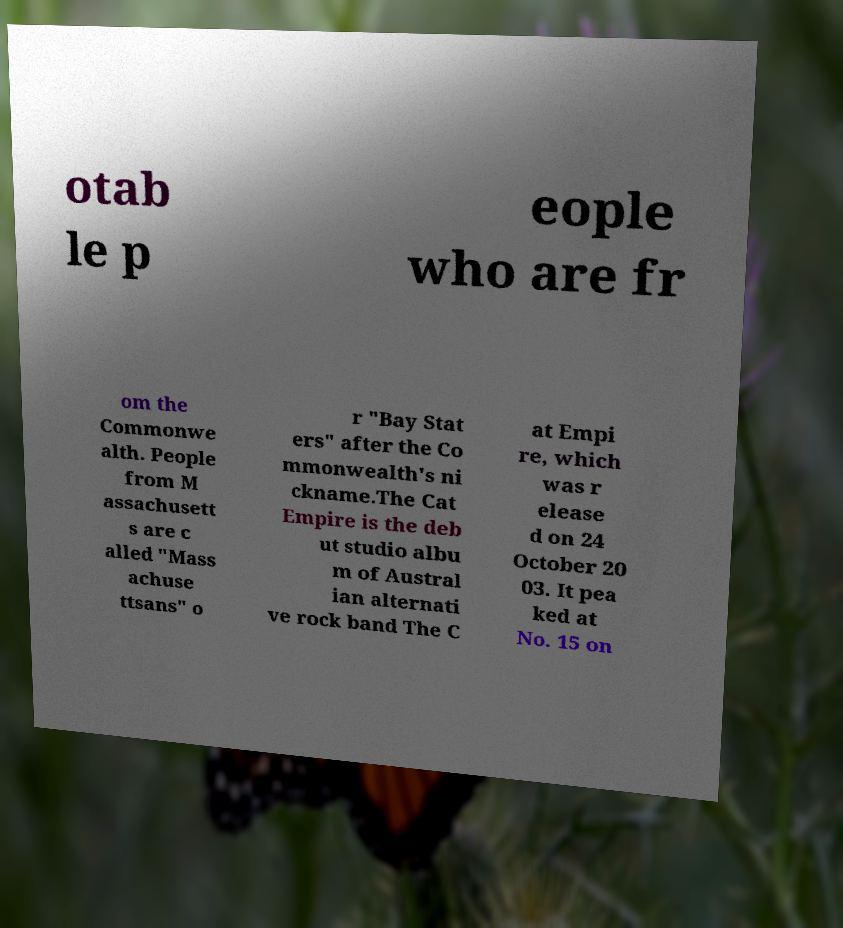Could you assist in decoding the text presented in this image and type it out clearly? otab le p eople who are fr om the Commonwe alth. People from M assachusett s are c alled "Mass achuse ttsans" o r "Bay Stat ers" after the Co mmonwealth's ni ckname.The Cat Empire is the deb ut studio albu m of Austral ian alternati ve rock band The C at Empi re, which was r elease d on 24 October 20 03. It pea ked at No. 15 on 